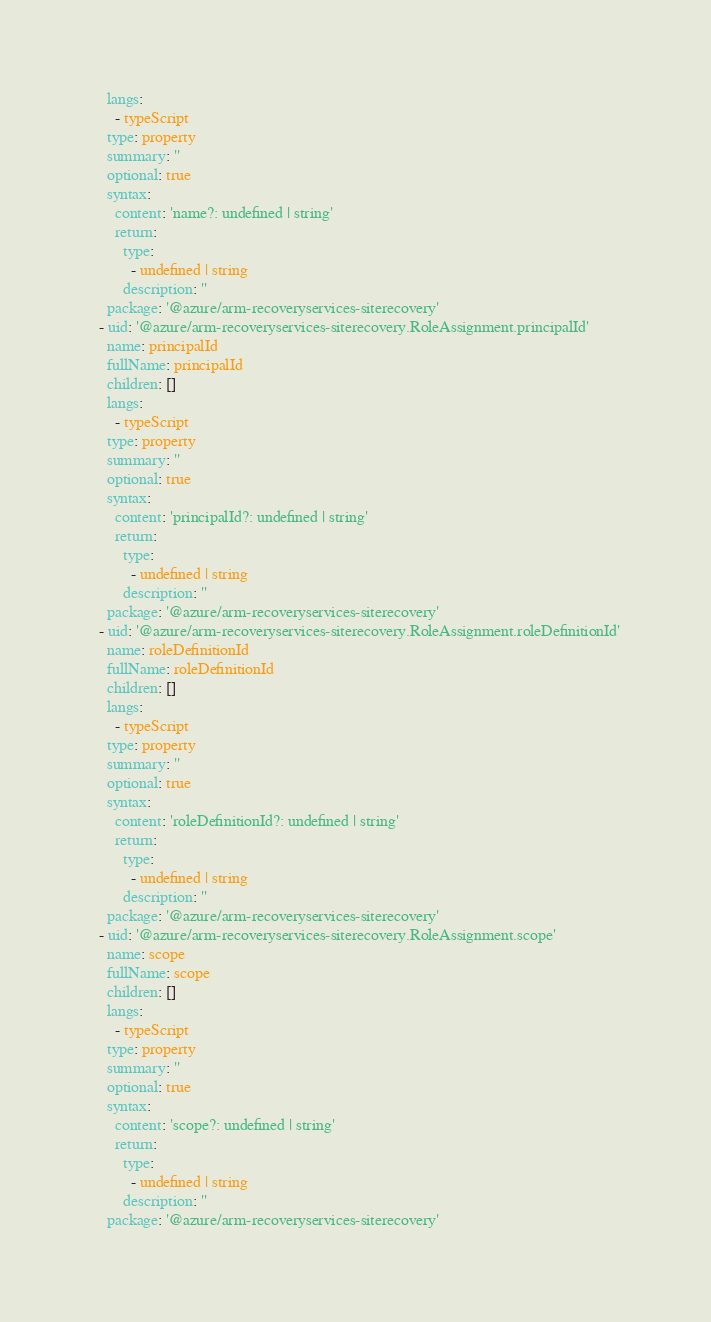Convert code to text. <code><loc_0><loc_0><loc_500><loc_500><_YAML_>    langs:
      - typeScript
    type: property
    summary: ''
    optional: true
    syntax:
      content: 'name?: undefined | string'
      return:
        type:
          - undefined | string
        description: ''
    package: '@azure/arm-recoveryservices-siterecovery'
  - uid: '@azure/arm-recoveryservices-siterecovery.RoleAssignment.principalId'
    name: principalId
    fullName: principalId
    children: []
    langs:
      - typeScript
    type: property
    summary: ''
    optional: true
    syntax:
      content: 'principalId?: undefined | string'
      return:
        type:
          - undefined | string
        description: ''
    package: '@azure/arm-recoveryservices-siterecovery'
  - uid: '@azure/arm-recoveryservices-siterecovery.RoleAssignment.roleDefinitionId'
    name: roleDefinitionId
    fullName: roleDefinitionId
    children: []
    langs:
      - typeScript
    type: property
    summary: ''
    optional: true
    syntax:
      content: 'roleDefinitionId?: undefined | string'
      return:
        type:
          - undefined | string
        description: ''
    package: '@azure/arm-recoveryservices-siterecovery'
  - uid: '@azure/arm-recoveryservices-siterecovery.RoleAssignment.scope'
    name: scope
    fullName: scope
    children: []
    langs:
      - typeScript
    type: property
    summary: ''
    optional: true
    syntax:
      content: 'scope?: undefined | string'
      return:
        type:
          - undefined | string
        description: ''
    package: '@azure/arm-recoveryservices-siterecovery'
</code> 